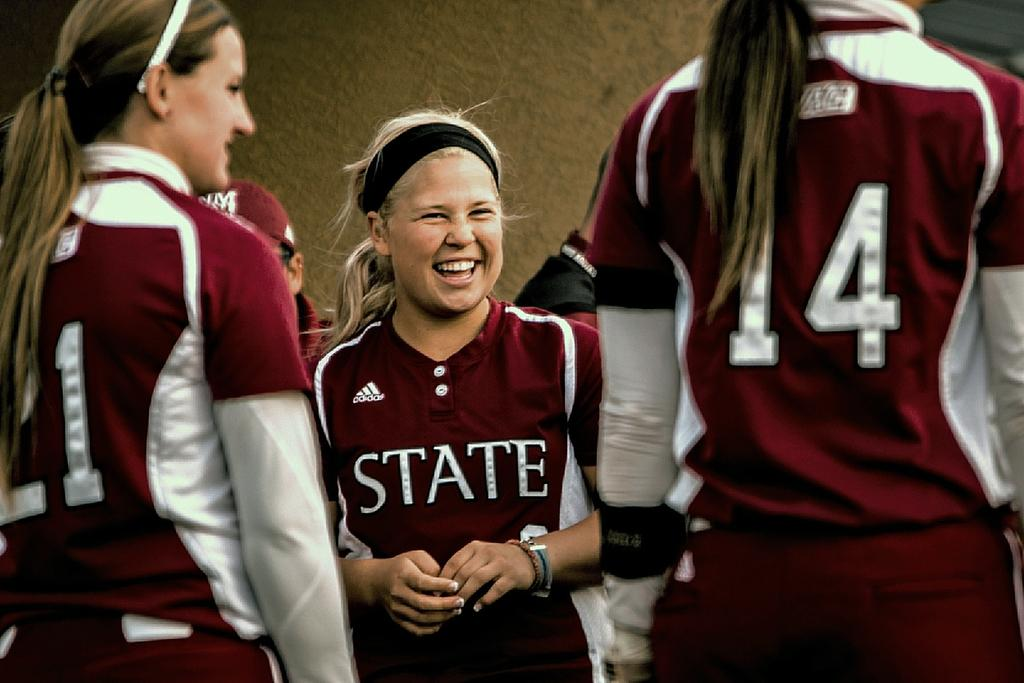<image>
Render a clear and concise summary of the photo. A group of cheerleaders are smiling and wearing matching burgundy uniforms that say State. 